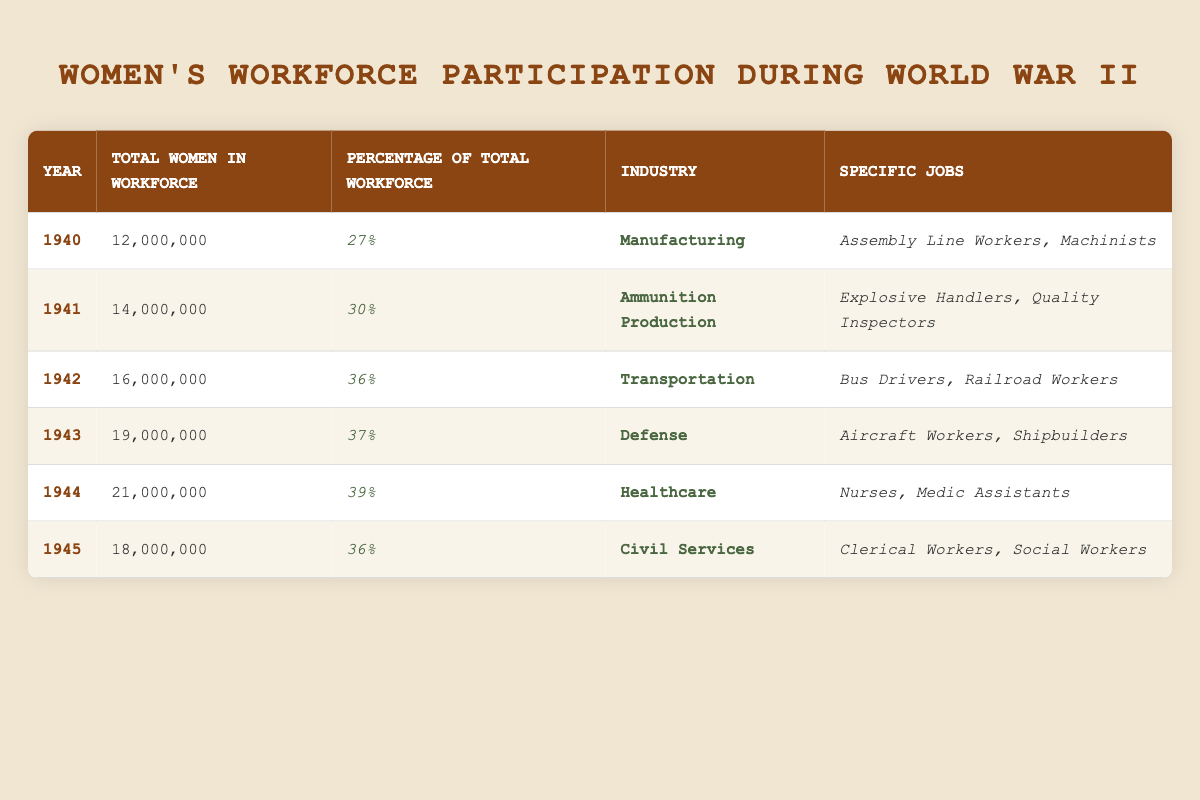What was the total number of women in the workforce in 1942? The table shows that in 1942, the total number of women in the workforce was listed as 16,000,000.
Answer: 16,000,000 What percentage of the total workforce did women represent in 1943? In 1943, the percentage of the total workforce that women represented is given as 37%.
Answer: 37% In which year did women's participation in the workforce first exceed 30%? Looking at the percentage values, women's participation first exceeded 30% in 1941 when it reached 30%.
Answer: 1941 What specific jobs were held by women in the healthcare industry in 1944? The specific jobs listed under the healthcare industry in 1944 include Nurses and Medic Assistants.
Answer: Nurses, Medic Assistants How many women were in the workforce in 1944 compared to 1943? In 1943, there were 19,000,000 women and in 1944, there were 21,000,000, thus the difference is 21,000,000 - 19,000,000 = 2,000,000 more women in 1944.
Answer: 2,000,000 Was there a decline in the total number of women in the workforce from 1944 to 1945? From 1944 to 1945, the workforce number dropped from 21,000,000 to 18,000,000, indicating a decline.
Answer: Yes What was the average percentage of women in the workforce across all years? To find the average, sum the percentages (27 + 30 + 36 + 37 + 39 + 36 = 205) and divide by 6 years, which gives approximately 34.17%.
Answer: Approximately 34.17% Which year had the highest number of women in the workforce and what was that number? The year 1944 had the highest total number of women in the workforce, which was 21,000,000.
Answer: 21,000,000 Did women's workforce participation increase every year during WWII? Analyzing the data, there was an increase from 1940 to 1944, but a decrease was observed in 1945. Thus, the participation did not increase every year.
Answer: No How many women were involved in the manufacturing industry in 1940? The table specifies that in 1940, the total number of women in the workforce was 12,000,000 and their main industry was manufacturing, including specific jobs such as Assembly Line Workers and Machinists.
Answer: 12,000,000 